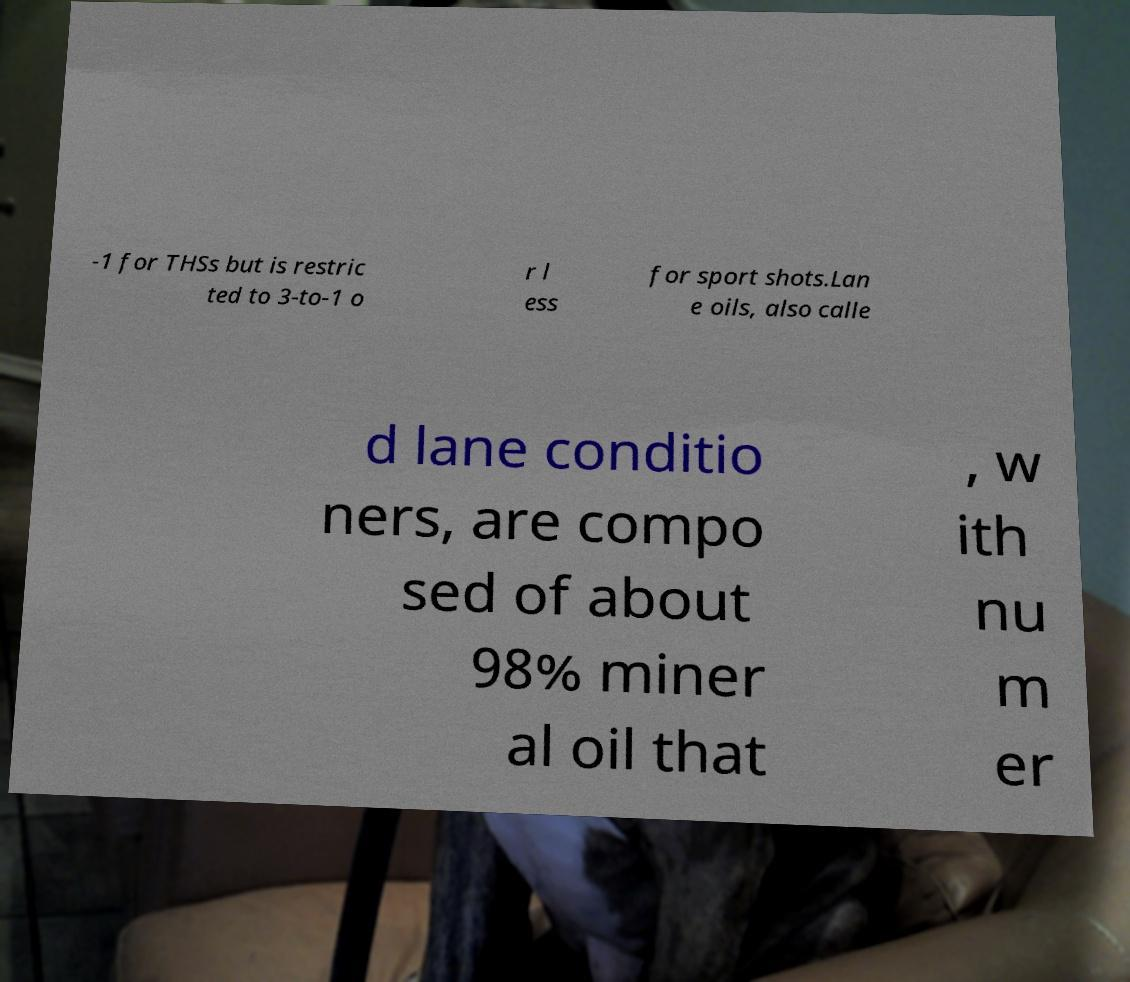Could you assist in decoding the text presented in this image and type it out clearly? -1 for THSs but is restric ted to 3-to-1 o r l ess for sport shots.Lan e oils, also calle d lane conditio ners, are compo sed of about 98% miner al oil that , w ith nu m er 